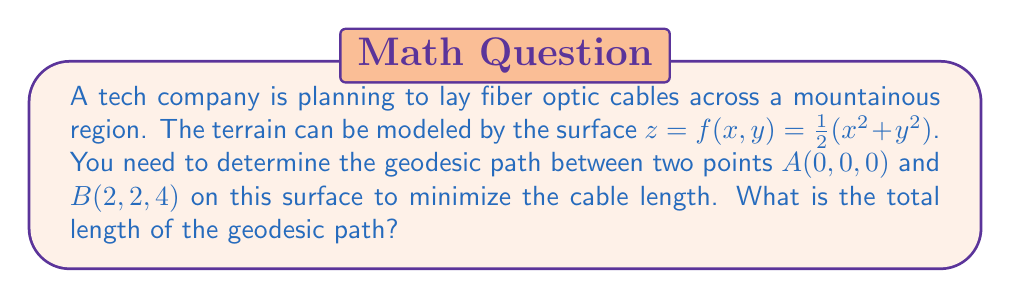Solve this math problem. To solve this problem, we'll follow these steps:

1) First, we need to calculate the metric tensor for the surface. The metric tensor is given by:

   $$g_{ij} = \begin{pmatrix}
   1 + (\frac{\partial f}{\partial x})^2 & \frac{\partial f}{\partial x}\frac{\partial f}{\partial y} \\
   \frac{\partial f}{\partial x}\frac{\partial f}{\partial y} & 1 + (\frac{\partial f}{\partial y})^2
   \end{pmatrix}$$

2) Calculate the partial derivatives:
   $\frac{\partial f}{\partial x} = x$, $\frac{\partial f}{\partial y} = y$

3) Substitute into the metric tensor:
   $$g_{ij} = \begin{pmatrix}
   1 + x^2 & xy \\
   xy & 1 + y^2
   \end{pmatrix}$$

4) The geodesic equations are:

   $$\frac{d^2x^i}{ds^2} + \Gamma^i_{jk}\frac{dx^j}{ds}\frac{dx^k}{ds} = 0$$

   where $\Gamma^i_{jk}$ are the Christoffel symbols.

5) Calculating the Christoffel symbols is complex, but for this surface, we can use a simpler approach. The geodesic on this surface is a straight line in the $(x,y)$ plane.

6) The straight line between $(0,0)$ and $(2,2)$ in the $(x,y)$ plane is given by $y = x$.

7) To find the length of the geodesic, we need to integrate:

   $$L = \int_0^2 \sqrt{1 + (\frac{dx}{ds})^2 + (\frac{dy}{ds})^2 + (\frac{dz}{ds})^2} ds$$

8) Along the geodesic, $\frac{dy}{ds} = \frac{dx}{ds}$ and $\frac{dz}{ds} = x\frac{dx}{ds} + y\frac{dy}{ds} = 2x\frac{dx}{ds}$

9) Substituting:

   $$L = \int_0^2 \sqrt{1 + (\frac{dx}{ds})^2 + (\frac{dx}{ds})^2 + 4x^2(\frac{dx}{ds})^2} ds$$
   $$= \int_0^2 \sqrt{1 + (2+4x^2)(\frac{dx}{ds})^2} ds$$

10) Using the substitution $u = \sqrt{1+x^2}$, $du = \frac{x}{\sqrt{1+x^2}}dx$, we get:

    $$L = \int_1^{\sqrt{5}} 2u du = 2[u^2/2]_1^{\sqrt{5}} = 2(\frac{5}{2} - \frac{1}{2}) = 4$$

Therefore, the total length of the geodesic path is 4 units.
Answer: 4 units 